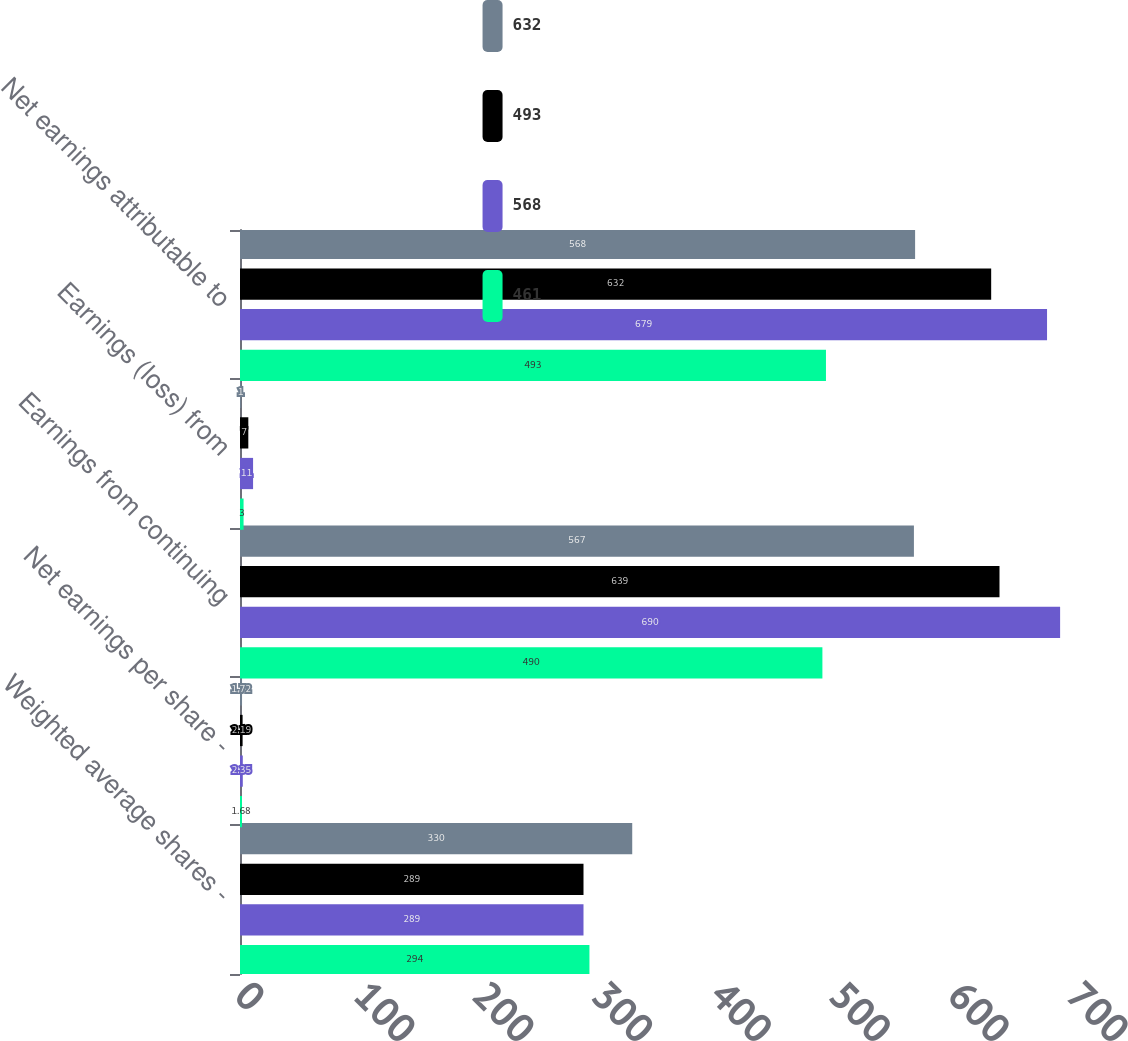Convert chart. <chart><loc_0><loc_0><loc_500><loc_500><stacked_bar_chart><ecel><fcel>Weighted average shares -<fcel>Net earnings per share -<fcel>Earnings from continuing<fcel>Earnings (loss) from<fcel>Net earnings attributable to<nl><fcel>632<fcel>330<fcel>1.72<fcel>567<fcel>1<fcel>568<nl><fcel>493<fcel>289<fcel>2.19<fcel>639<fcel>7<fcel>632<nl><fcel>568<fcel>289<fcel>2.35<fcel>690<fcel>11<fcel>679<nl><fcel>461<fcel>294<fcel>1.68<fcel>490<fcel>3<fcel>493<nl></chart> 